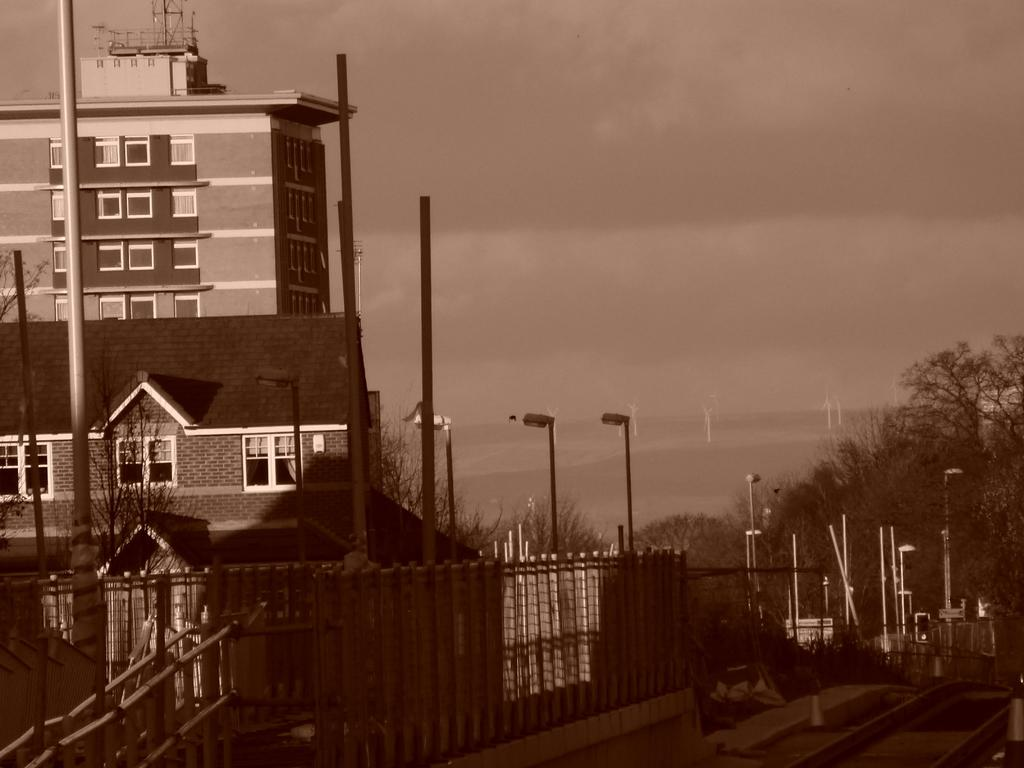What type of structures can be seen in the image? There are buildings in the image. What is the purpose of the fence in the image? The fence is likely used to separate or enclose areas in the image. What type of lighting is present in the image? There are street lights in the image. What other objects can be seen in the image? There are poles and a tower on a building in the image. What can be seen in the background of the image? There are trees and the sky visible in the background of the image. Where is the sea visible in the image? There is no sea present in the image; it features buildings, a fence, street lights, poles, a tower, trees, and the sky. What type of hands are holding the tower in the image? There are no hands visible in the image, and the tower is on a building, not being held by any hands. 